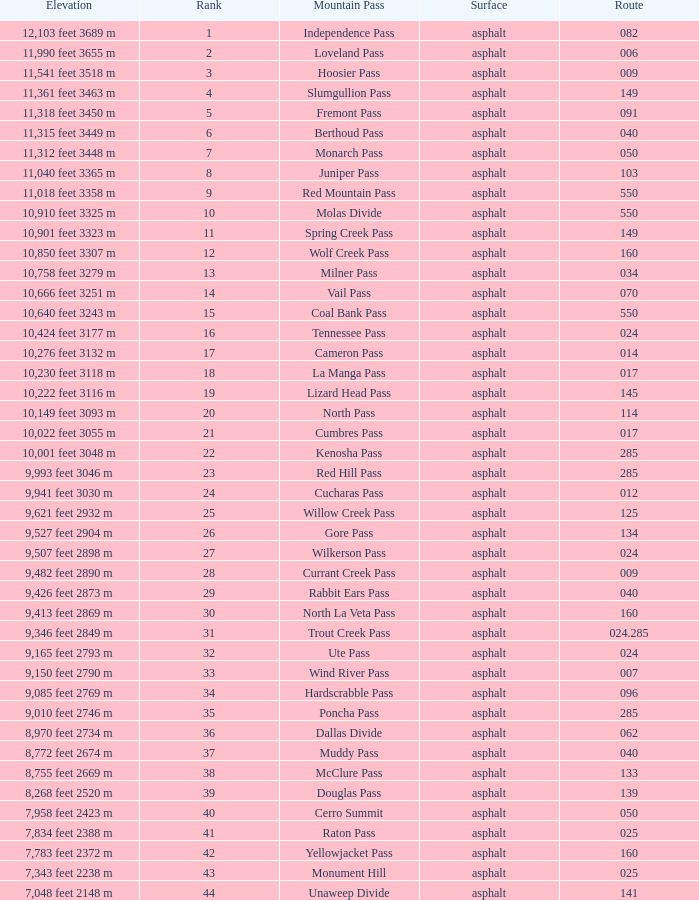What is the Elevation of the mountain on Route 62? 8,970 feet 2734 m. 